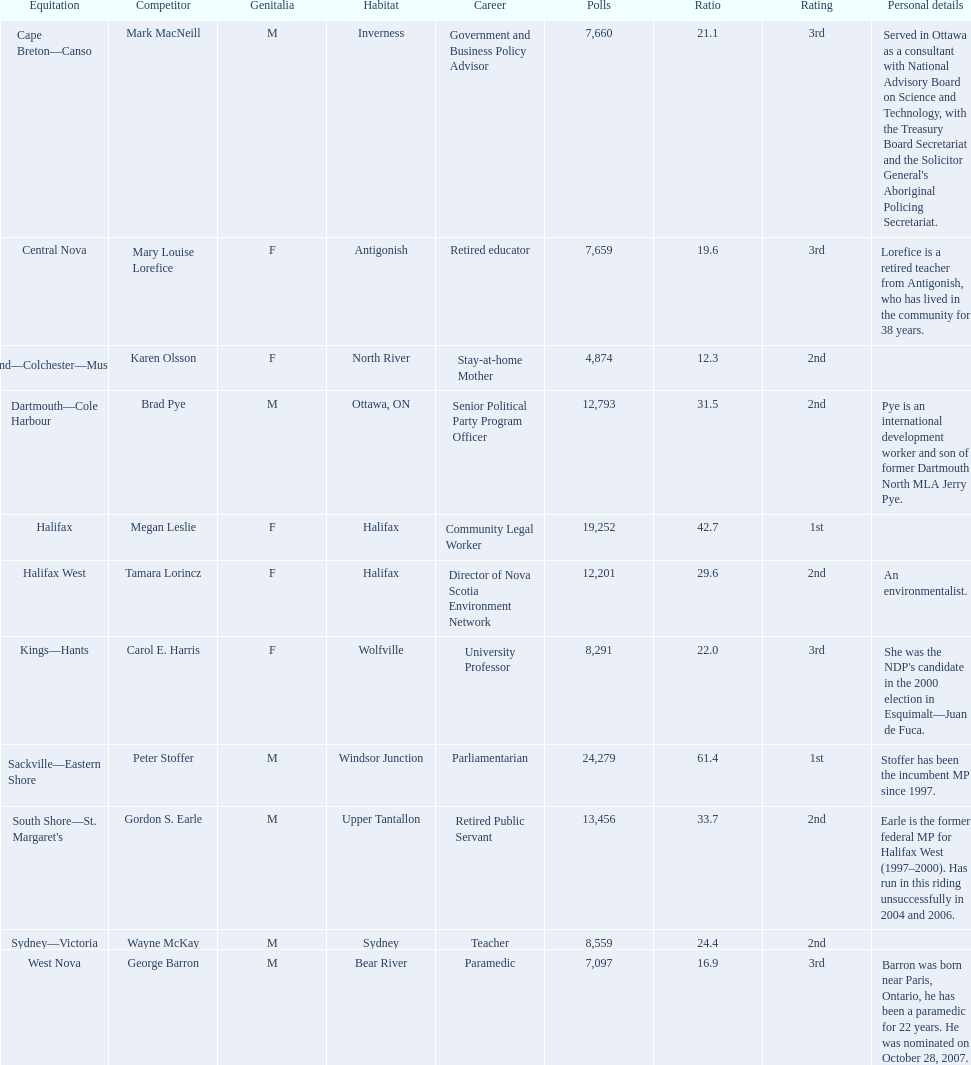What new democratic party candidates ran in the 2008 canadian federal election? Mark MacNeill, Mary Louise Lorefice, Karen Olsson, Brad Pye, Megan Leslie, Tamara Lorincz, Carol E. Harris, Peter Stoffer, Gordon S. Earle, Wayne McKay, George Barron. Of these candidates, which are female? Mary Louise Lorefice, Karen Olsson, Megan Leslie, Tamara Lorincz, Carol E. Harris. Which of these candidates resides in halifax? Megan Leslie, Tamara Lorincz. Of the remaining two, which was ranked 1st? Megan Leslie. How many votes did she get? 19,252. 